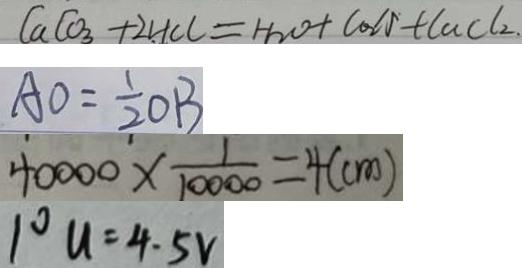<formula> <loc_0><loc_0><loc_500><loc_500>C a C O _ { 3 } + 2 H C l = H _ { 2 } O + C O _ { 2 } \uparrow + C a C l _ { 2 } . 
 A O = \frac { 1 } { 2 } O B 
 4 0 0 0 0 \times \frac { 1 } { 1 0 0 0 0 } = 4 ( c m ) 
 1 ^ { \circ } u = 4 . 5 V</formula> 